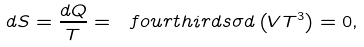Convert formula to latex. <formula><loc_0><loc_0><loc_500><loc_500>d S = \frac { d Q } { T } = \ f o u r t h i r d s \sigma d \left ( V T ^ { 3 } \right ) = 0 ,</formula> 